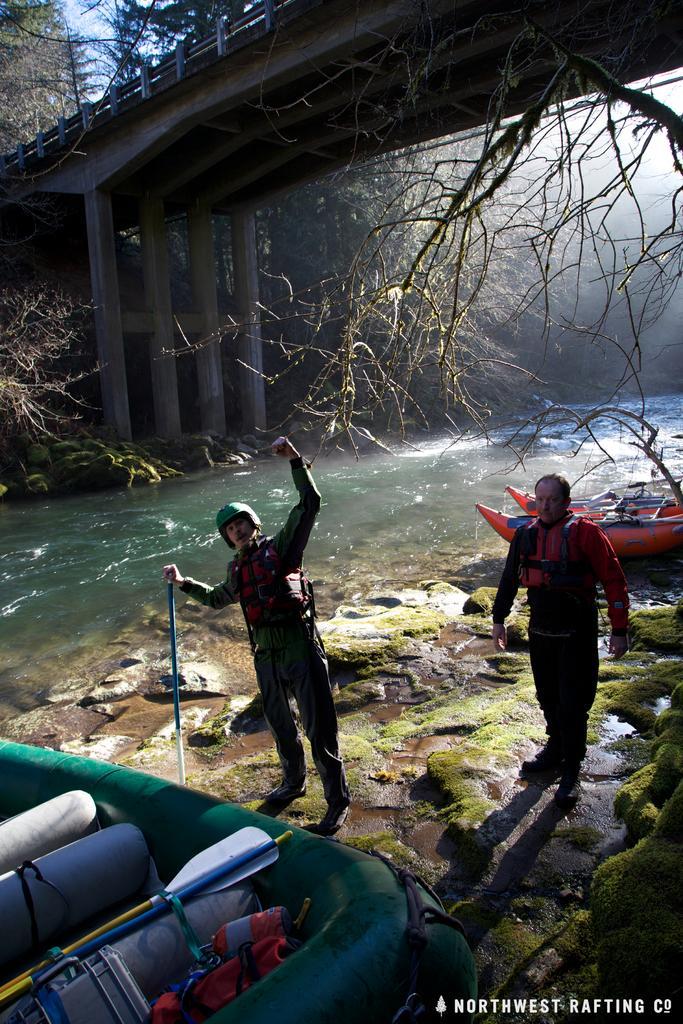Please provide a concise description of this image. In the picture I can see two men. There is a man on the right side is wearing the safety jacket. I can see another man on the left side is wearing the safety and there is a helmet on his head. He is holding a stick in his right hand. I can see the boats. There is a bridge construction at the top of the picture. In the picture I can see the water and trees. 